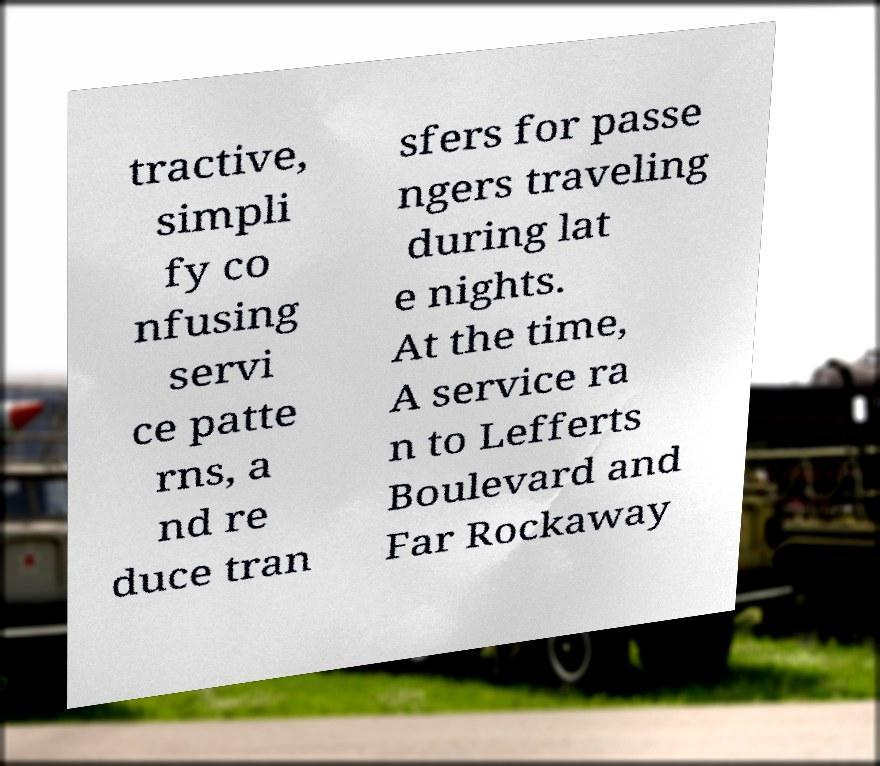Could you extract and type out the text from this image? tractive, simpli fy co nfusing servi ce patte rns, a nd re duce tran sfers for passe ngers traveling during lat e nights. At the time, A service ra n to Lefferts Boulevard and Far Rockaway 